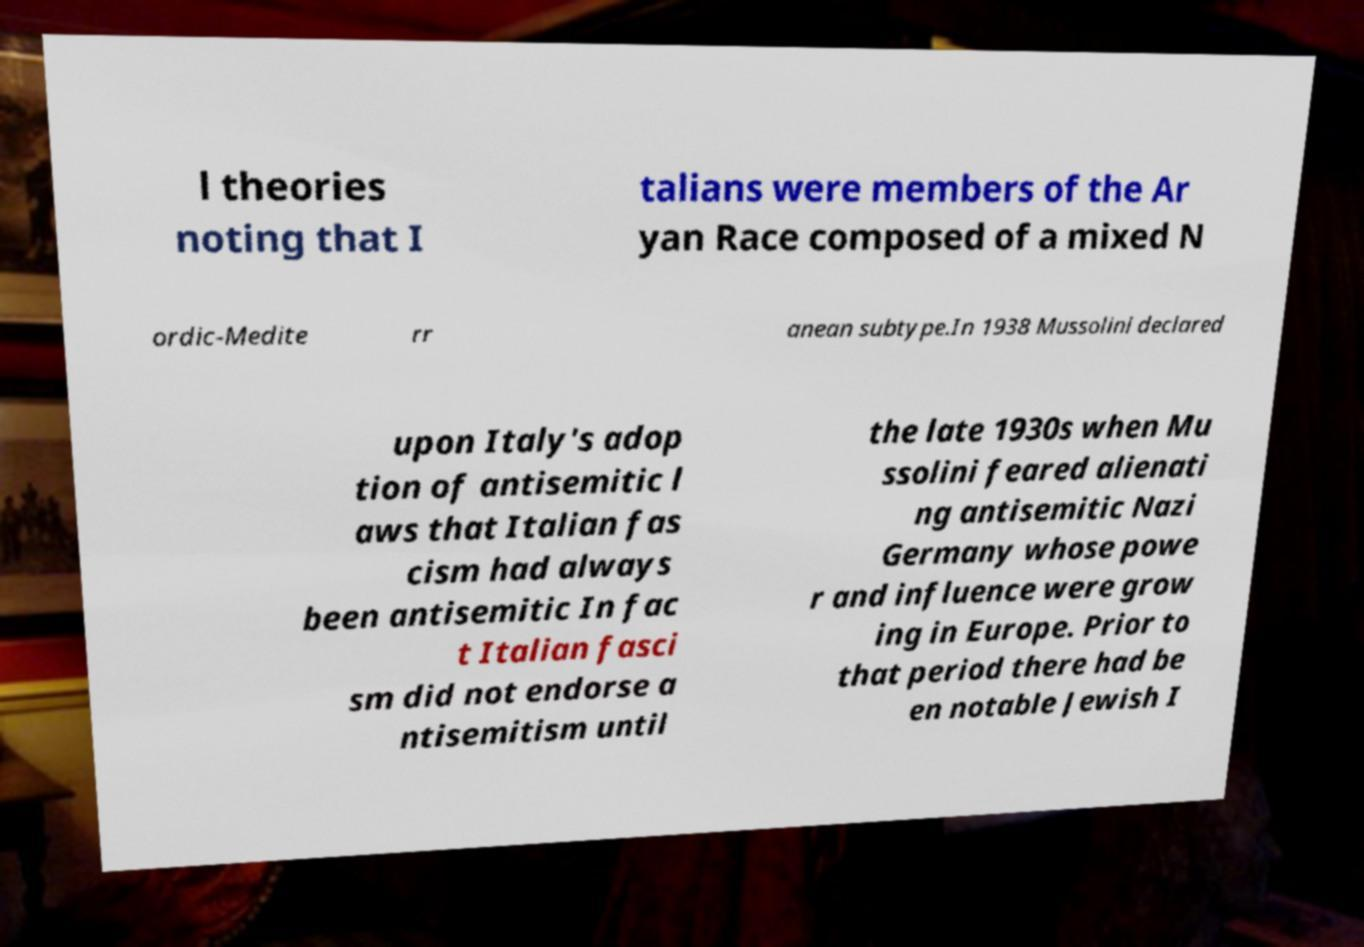I need the written content from this picture converted into text. Can you do that? l theories noting that I talians were members of the Ar yan Race composed of a mixed N ordic-Medite rr anean subtype.In 1938 Mussolini declared upon Italy's adop tion of antisemitic l aws that Italian fas cism had always been antisemitic In fac t Italian fasci sm did not endorse a ntisemitism until the late 1930s when Mu ssolini feared alienati ng antisemitic Nazi Germany whose powe r and influence were grow ing in Europe. Prior to that period there had be en notable Jewish I 